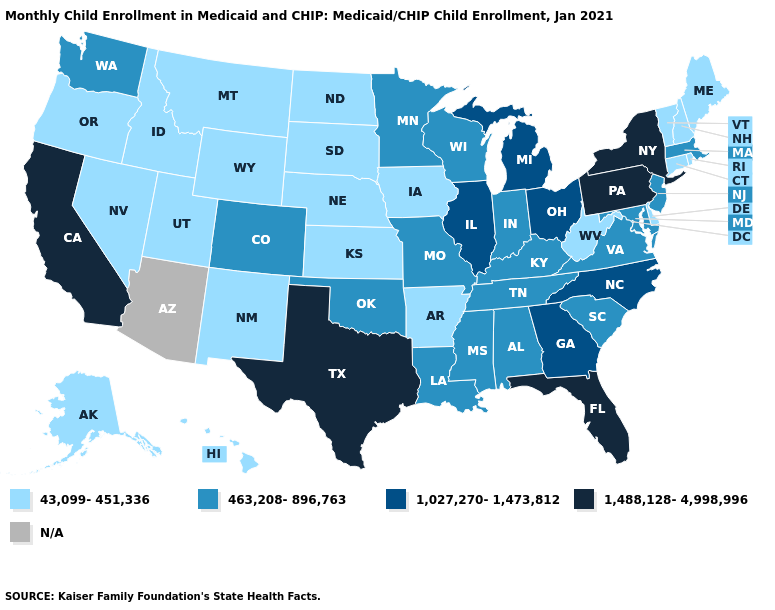What is the highest value in states that border Alabama?
Be succinct. 1,488,128-4,998,996. Which states have the highest value in the USA?
Write a very short answer. California, Florida, New York, Pennsylvania, Texas. Name the states that have a value in the range 43,099-451,336?
Give a very brief answer. Alaska, Arkansas, Connecticut, Delaware, Hawaii, Idaho, Iowa, Kansas, Maine, Montana, Nebraska, Nevada, New Hampshire, New Mexico, North Dakota, Oregon, Rhode Island, South Dakota, Utah, Vermont, West Virginia, Wyoming. Does Wisconsin have the highest value in the MidWest?
Be succinct. No. Name the states that have a value in the range 1,027,270-1,473,812?
Short answer required. Georgia, Illinois, Michigan, North Carolina, Ohio. What is the value of Maine?
Write a very short answer. 43,099-451,336. Name the states that have a value in the range N/A?
Short answer required. Arizona. Does the map have missing data?
Be succinct. Yes. What is the value of Vermont?
Short answer required. 43,099-451,336. Name the states that have a value in the range 463,208-896,763?
Write a very short answer. Alabama, Colorado, Indiana, Kentucky, Louisiana, Maryland, Massachusetts, Minnesota, Mississippi, Missouri, New Jersey, Oklahoma, South Carolina, Tennessee, Virginia, Washington, Wisconsin. What is the value of Alabama?
Answer briefly. 463,208-896,763. How many symbols are there in the legend?
Quick response, please. 5. What is the highest value in states that border Arizona?
Write a very short answer. 1,488,128-4,998,996. What is the value of Oregon?
Concise answer only. 43,099-451,336. 